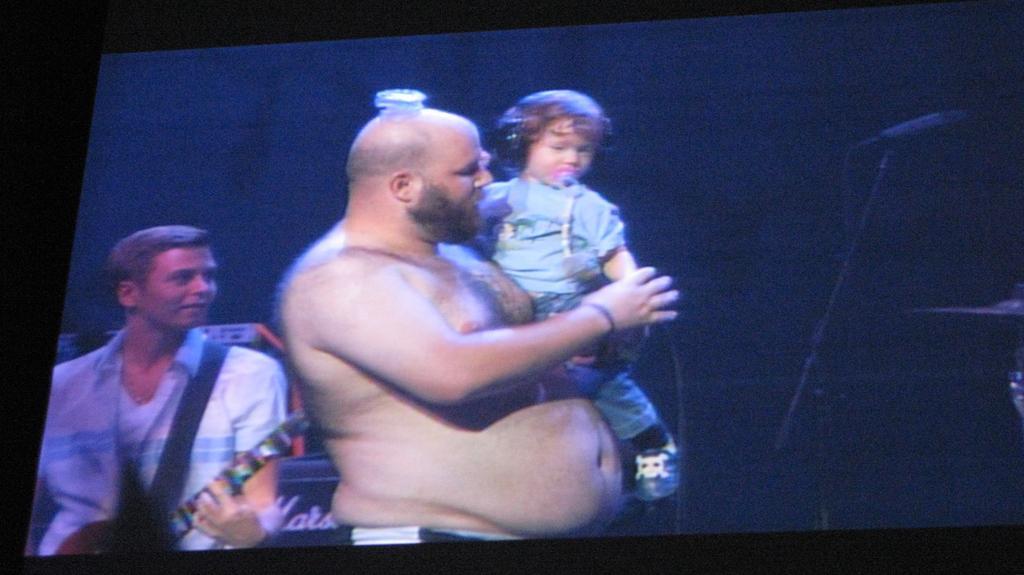How would you summarize this image in a sentence or two? In this image, we can see a screen. In the background, there is a dark view. On this screen, we can see a person holding a kid and keeping an object on his head. Another person holding a musical instrument. We can see a microphone, rod and few objects. Kid wearing headphones and holding a pacifier with his mouth. 